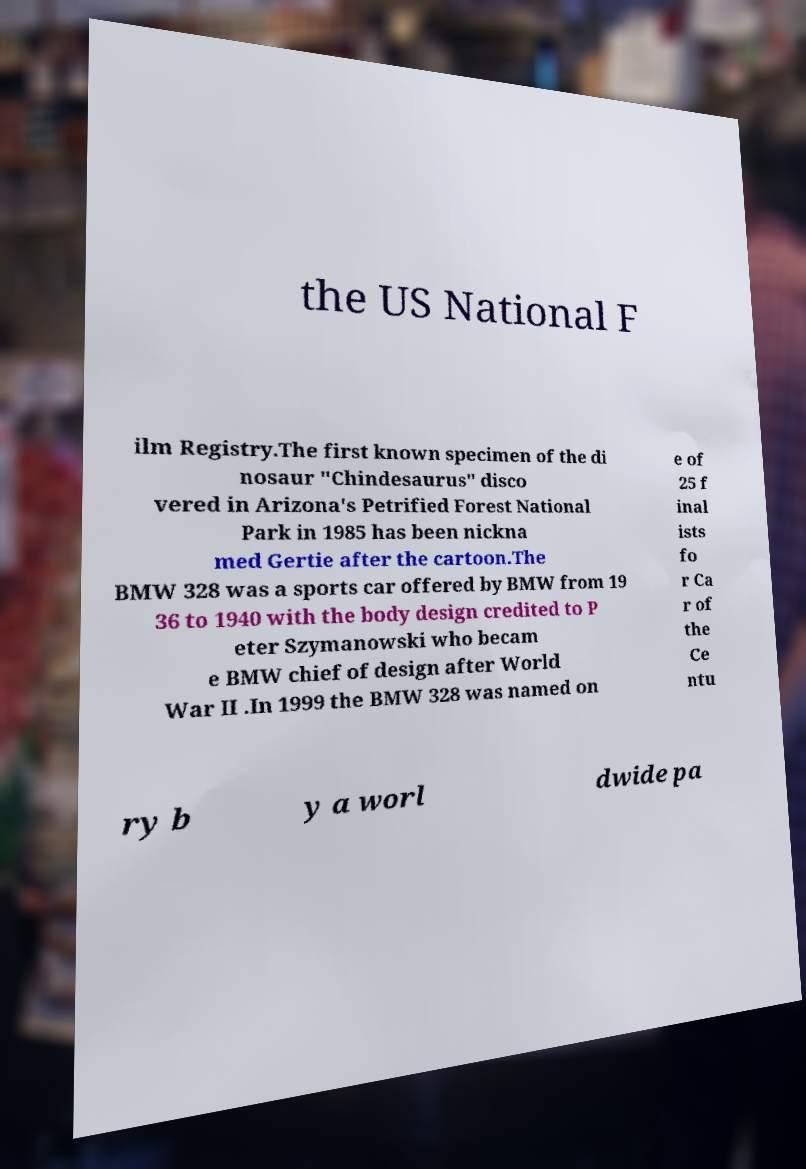Can you read and provide the text displayed in the image?This photo seems to have some interesting text. Can you extract and type it out for me? the US National F ilm Registry.The first known specimen of the di nosaur "Chindesaurus" disco vered in Arizona's Petrified Forest National Park in 1985 has been nickna med Gertie after the cartoon.The BMW 328 was a sports car offered by BMW from 19 36 to 1940 with the body design credited to P eter Szymanowski who becam e BMW chief of design after World War II .In 1999 the BMW 328 was named on e of 25 f inal ists fo r Ca r of the Ce ntu ry b y a worl dwide pa 